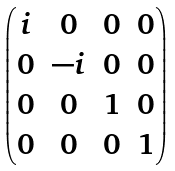<formula> <loc_0><loc_0><loc_500><loc_500>\begin{pmatrix} i & 0 & 0 & 0 \\ 0 & - i & 0 & 0 \\ 0 & 0 & 1 & 0 \\ 0 & 0 & 0 & 1 \end{pmatrix}</formula> 